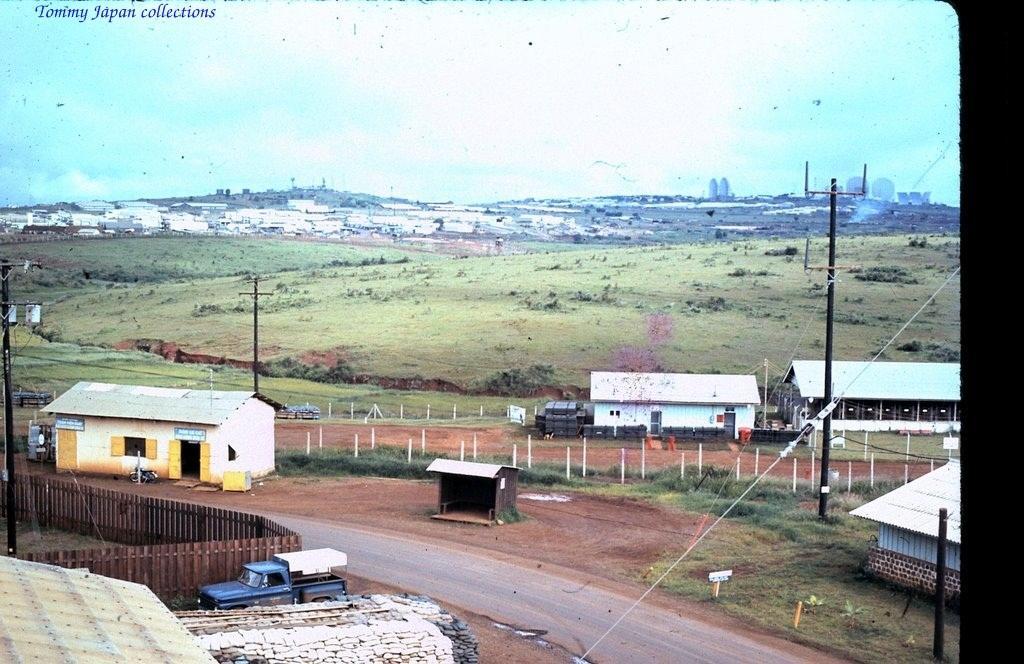How would you summarize this image in a sentence or two? This is an edited picture. In this image there are buildings and trees and poles and there is a vehicle and there are railings. At the top there is sky and there are clouds and there is text. At the bottom there is grass and there is ground and there is a road. 